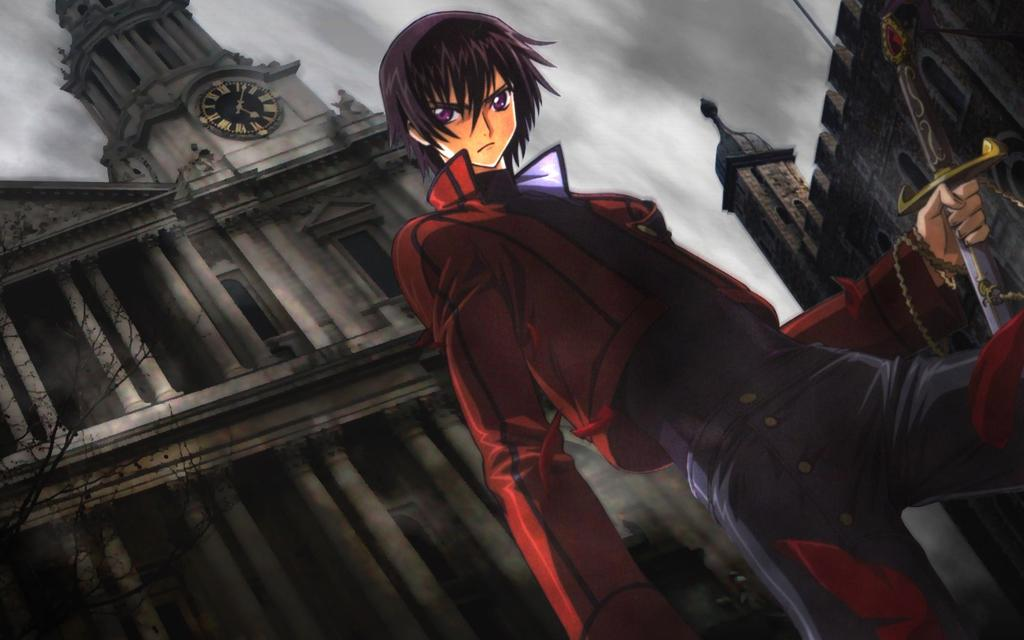What type of media is the image? The image is an animation. What is the man in the image holding? The man is holding a sword in the image. What can be seen in the background of the image? There are buildings and the sky visible in the background of the image. Where is the tree located in the image? The tree is on the left side of the image. What type of linen is draped over the buildings in the image? There is no linen draped over the buildings in the image; it is an animation with buildings and a sky in the background. 